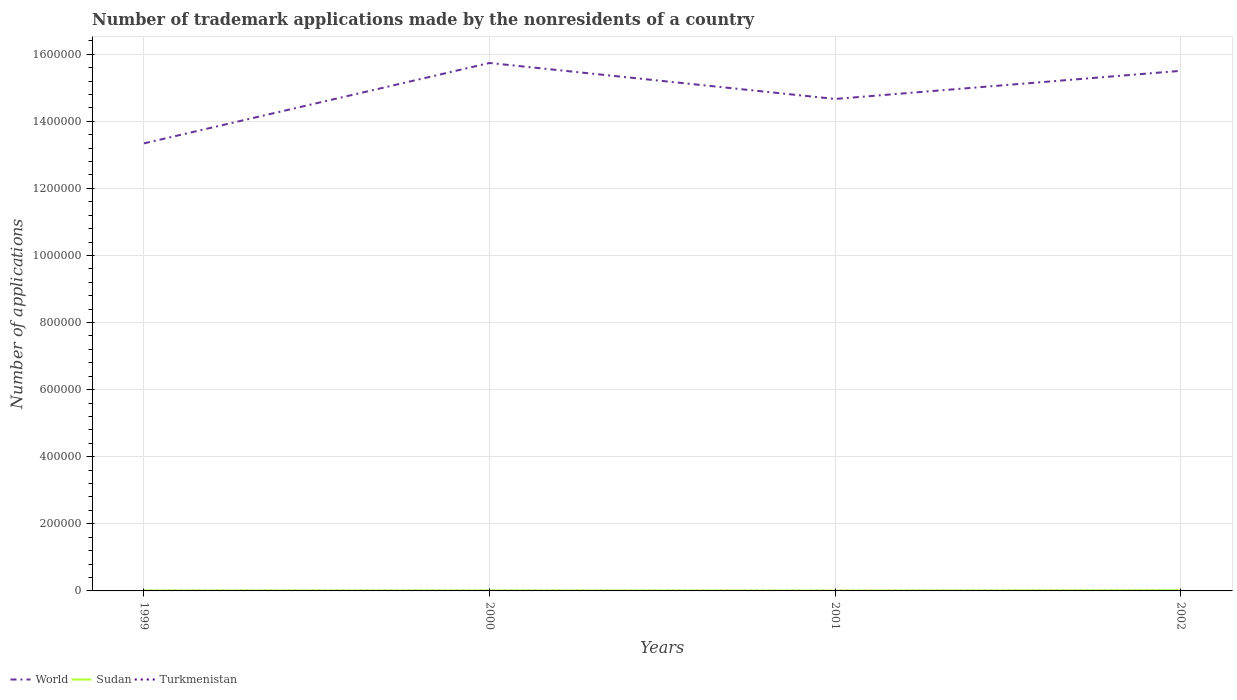Does the line corresponding to World intersect with the line corresponding to Turkmenistan?
Offer a very short reply. No. Across all years, what is the maximum number of trademark applications made by the nonresidents in Sudan?
Provide a succinct answer. 805. In which year was the number of trademark applications made by the nonresidents in Turkmenistan maximum?
Offer a terse response. 2001. What is the total number of trademark applications made by the nonresidents in Sudan in the graph?
Provide a short and direct response. -782. What is the difference between the highest and the second highest number of trademark applications made by the nonresidents in Sudan?
Ensure brevity in your answer.  1047. Is the number of trademark applications made by the nonresidents in World strictly greater than the number of trademark applications made by the nonresidents in Sudan over the years?
Ensure brevity in your answer.  No. How many lines are there?
Your response must be concise. 3. How many years are there in the graph?
Ensure brevity in your answer.  4. Does the graph contain any zero values?
Give a very brief answer. No. Does the graph contain grids?
Offer a terse response. Yes. Where does the legend appear in the graph?
Ensure brevity in your answer.  Bottom left. How many legend labels are there?
Keep it short and to the point. 3. How are the legend labels stacked?
Offer a terse response. Horizontal. What is the title of the graph?
Provide a short and direct response. Number of trademark applications made by the nonresidents of a country. What is the label or title of the Y-axis?
Ensure brevity in your answer.  Number of applications. What is the Number of applications in World in 1999?
Give a very brief answer. 1.33e+06. What is the Number of applications in Sudan in 1999?
Your answer should be very brief. 1070. What is the Number of applications in Turkmenistan in 1999?
Provide a succinct answer. 109. What is the Number of applications in World in 2000?
Provide a short and direct response. 1.57e+06. What is the Number of applications of Sudan in 2000?
Ensure brevity in your answer.  1238. What is the Number of applications of Turkmenistan in 2000?
Offer a very short reply. 79. What is the Number of applications of World in 2001?
Give a very brief answer. 1.47e+06. What is the Number of applications of Sudan in 2001?
Provide a succinct answer. 805. What is the Number of applications of World in 2002?
Your response must be concise. 1.55e+06. What is the Number of applications of Sudan in 2002?
Offer a terse response. 1852. What is the Number of applications in Turkmenistan in 2002?
Provide a succinct answer. 103. Across all years, what is the maximum Number of applications of World?
Provide a succinct answer. 1.57e+06. Across all years, what is the maximum Number of applications of Sudan?
Your answer should be very brief. 1852. Across all years, what is the maximum Number of applications in Turkmenistan?
Provide a succinct answer. 109. Across all years, what is the minimum Number of applications in World?
Make the answer very short. 1.33e+06. Across all years, what is the minimum Number of applications in Sudan?
Provide a succinct answer. 805. What is the total Number of applications of World in the graph?
Keep it short and to the point. 5.92e+06. What is the total Number of applications in Sudan in the graph?
Your answer should be compact. 4965. What is the total Number of applications in Turkmenistan in the graph?
Keep it short and to the point. 337. What is the difference between the Number of applications of World in 1999 and that in 2000?
Your answer should be very brief. -2.40e+05. What is the difference between the Number of applications in Sudan in 1999 and that in 2000?
Ensure brevity in your answer.  -168. What is the difference between the Number of applications in World in 1999 and that in 2001?
Give a very brief answer. -1.32e+05. What is the difference between the Number of applications of Sudan in 1999 and that in 2001?
Offer a very short reply. 265. What is the difference between the Number of applications of Turkmenistan in 1999 and that in 2001?
Ensure brevity in your answer.  63. What is the difference between the Number of applications of World in 1999 and that in 2002?
Provide a short and direct response. -2.16e+05. What is the difference between the Number of applications of Sudan in 1999 and that in 2002?
Make the answer very short. -782. What is the difference between the Number of applications in Turkmenistan in 1999 and that in 2002?
Ensure brevity in your answer.  6. What is the difference between the Number of applications in World in 2000 and that in 2001?
Your answer should be compact. 1.07e+05. What is the difference between the Number of applications in Sudan in 2000 and that in 2001?
Your answer should be compact. 433. What is the difference between the Number of applications in World in 2000 and that in 2002?
Provide a short and direct response. 2.34e+04. What is the difference between the Number of applications of Sudan in 2000 and that in 2002?
Offer a very short reply. -614. What is the difference between the Number of applications of World in 2001 and that in 2002?
Your answer should be compact. -8.39e+04. What is the difference between the Number of applications of Sudan in 2001 and that in 2002?
Your answer should be very brief. -1047. What is the difference between the Number of applications of Turkmenistan in 2001 and that in 2002?
Offer a terse response. -57. What is the difference between the Number of applications in World in 1999 and the Number of applications in Sudan in 2000?
Make the answer very short. 1.33e+06. What is the difference between the Number of applications in World in 1999 and the Number of applications in Turkmenistan in 2000?
Keep it short and to the point. 1.33e+06. What is the difference between the Number of applications of Sudan in 1999 and the Number of applications of Turkmenistan in 2000?
Give a very brief answer. 991. What is the difference between the Number of applications of World in 1999 and the Number of applications of Sudan in 2001?
Give a very brief answer. 1.33e+06. What is the difference between the Number of applications of World in 1999 and the Number of applications of Turkmenistan in 2001?
Offer a very short reply. 1.33e+06. What is the difference between the Number of applications in Sudan in 1999 and the Number of applications in Turkmenistan in 2001?
Provide a succinct answer. 1024. What is the difference between the Number of applications of World in 1999 and the Number of applications of Sudan in 2002?
Offer a very short reply. 1.33e+06. What is the difference between the Number of applications in World in 1999 and the Number of applications in Turkmenistan in 2002?
Your response must be concise. 1.33e+06. What is the difference between the Number of applications of Sudan in 1999 and the Number of applications of Turkmenistan in 2002?
Ensure brevity in your answer.  967. What is the difference between the Number of applications in World in 2000 and the Number of applications in Sudan in 2001?
Give a very brief answer. 1.57e+06. What is the difference between the Number of applications in World in 2000 and the Number of applications in Turkmenistan in 2001?
Your answer should be compact. 1.57e+06. What is the difference between the Number of applications of Sudan in 2000 and the Number of applications of Turkmenistan in 2001?
Offer a terse response. 1192. What is the difference between the Number of applications of World in 2000 and the Number of applications of Sudan in 2002?
Your response must be concise. 1.57e+06. What is the difference between the Number of applications in World in 2000 and the Number of applications in Turkmenistan in 2002?
Ensure brevity in your answer.  1.57e+06. What is the difference between the Number of applications in Sudan in 2000 and the Number of applications in Turkmenistan in 2002?
Provide a short and direct response. 1135. What is the difference between the Number of applications in World in 2001 and the Number of applications in Sudan in 2002?
Provide a short and direct response. 1.46e+06. What is the difference between the Number of applications of World in 2001 and the Number of applications of Turkmenistan in 2002?
Give a very brief answer. 1.47e+06. What is the difference between the Number of applications of Sudan in 2001 and the Number of applications of Turkmenistan in 2002?
Your answer should be very brief. 702. What is the average Number of applications of World per year?
Your answer should be very brief. 1.48e+06. What is the average Number of applications of Sudan per year?
Provide a short and direct response. 1241.25. What is the average Number of applications in Turkmenistan per year?
Your answer should be very brief. 84.25. In the year 1999, what is the difference between the Number of applications in World and Number of applications in Sudan?
Ensure brevity in your answer.  1.33e+06. In the year 1999, what is the difference between the Number of applications of World and Number of applications of Turkmenistan?
Make the answer very short. 1.33e+06. In the year 1999, what is the difference between the Number of applications in Sudan and Number of applications in Turkmenistan?
Your response must be concise. 961. In the year 2000, what is the difference between the Number of applications of World and Number of applications of Sudan?
Give a very brief answer. 1.57e+06. In the year 2000, what is the difference between the Number of applications of World and Number of applications of Turkmenistan?
Ensure brevity in your answer.  1.57e+06. In the year 2000, what is the difference between the Number of applications in Sudan and Number of applications in Turkmenistan?
Give a very brief answer. 1159. In the year 2001, what is the difference between the Number of applications in World and Number of applications in Sudan?
Provide a succinct answer. 1.47e+06. In the year 2001, what is the difference between the Number of applications in World and Number of applications in Turkmenistan?
Ensure brevity in your answer.  1.47e+06. In the year 2001, what is the difference between the Number of applications in Sudan and Number of applications in Turkmenistan?
Your response must be concise. 759. In the year 2002, what is the difference between the Number of applications in World and Number of applications in Sudan?
Give a very brief answer. 1.55e+06. In the year 2002, what is the difference between the Number of applications of World and Number of applications of Turkmenistan?
Offer a terse response. 1.55e+06. In the year 2002, what is the difference between the Number of applications of Sudan and Number of applications of Turkmenistan?
Keep it short and to the point. 1749. What is the ratio of the Number of applications in World in 1999 to that in 2000?
Keep it short and to the point. 0.85. What is the ratio of the Number of applications in Sudan in 1999 to that in 2000?
Give a very brief answer. 0.86. What is the ratio of the Number of applications of Turkmenistan in 1999 to that in 2000?
Your response must be concise. 1.38. What is the ratio of the Number of applications of World in 1999 to that in 2001?
Provide a succinct answer. 0.91. What is the ratio of the Number of applications in Sudan in 1999 to that in 2001?
Your answer should be very brief. 1.33. What is the ratio of the Number of applications of Turkmenistan in 1999 to that in 2001?
Your answer should be compact. 2.37. What is the ratio of the Number of applications in World in 1999 to that in 2002?
Ensure brevity in your answer.  0.86. What is the ratio of the Number of applications of Sudan in 1999 to that in 2002?
Your answer should be compact. 0.58. What is the ratio of the Number of applications of Turkmenistan in 1999 to that in 2002?
Offer a very short reply. 1.06. What is the ratio of the Number of applications in World in 2000 to that in 2001?
Ensure brevity in your answer.  1.07. What is the ratio of the Number of applications in Sudan in 2000 to that in 2001?
Keep it short and to the point. 1.54. What is the ratio of the Number of applications of Turkmenistan in 2000 to that in 2001?
Ensure brevity in your answer.  1.72. What is the ratio of the Number of applications of World in 2000 to that in 2002?
Offer a terse response. 1.02. What is the ratio of the Number of applications in Sudan in 2000 to that in 2002?
Give a very brief answer. 0.67. What is the ratio of the Number of applications in Turkmenistan in 2000 to that in 2002?
Offer a very short reply. 0.77. What is the ratio of the Number of applications of World in 2001 to that in 2002?
Your response must be concise. 0.95. What is the ratio of the Number of applications of Sudan in 2001 to that in 2002?
Provide a succinct answer. 0.43. What is the ratio of the Number of applications in Turkmenistan in 2001 to that in 2002?
Provide a short and direct response. 0.45. What is the difference between the highest and the second highest Number of applications of World?
Give a very brief answer. 2.34e+04. What is the difference between the highest and the second highest Number of applications in Sudan?
Ensure brevity in your answer.  614. What is the difference between the highest and the second highest Number of applications in Turkmenistan?
Your answer should be very brief. 6. What is the difference between the highest and the lowest Number of applications in World?
Give a very brief answer. 2.40e+05. What is the difference between the highest and the lowest Number of applications in Sudan?
Ensure brevity in your answer.  1047. 